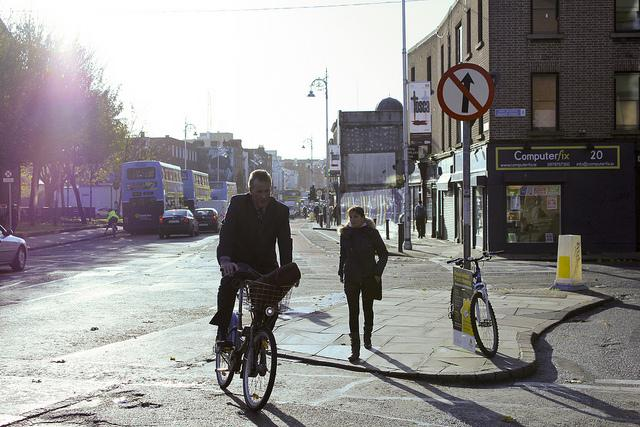Where is the man on the bicycle possibly going? Please explain your reasoning. work. The man is wearing a suit. 